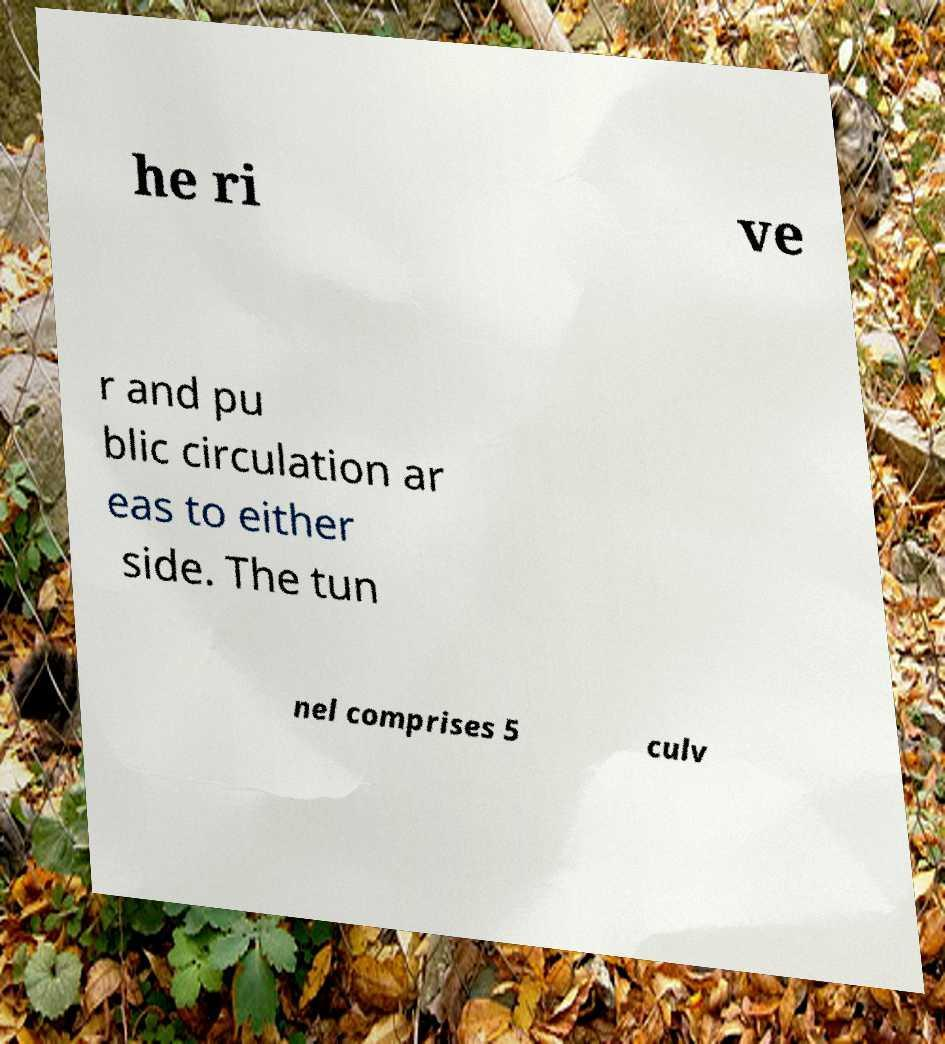I need the written content from this picture converted into text. Can you do that? he ri ve r and pu blic circulation ar eas to either side. The tun nel comprises 5 culv 